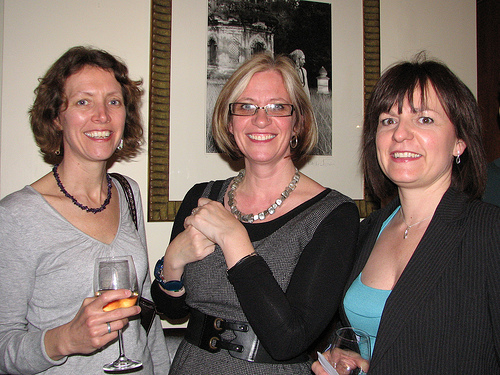<image>
Can you confirm if the necklace is on the woman? No. The necklace is not positioned on the woman. They may be near each other, but the necklace is not supported by or resting on top of the woman. Is there a photo behind the lady? Yes. From this viewpoint, the photo is positioned behind the lady, with the lady partially or fully occluding the photo. 